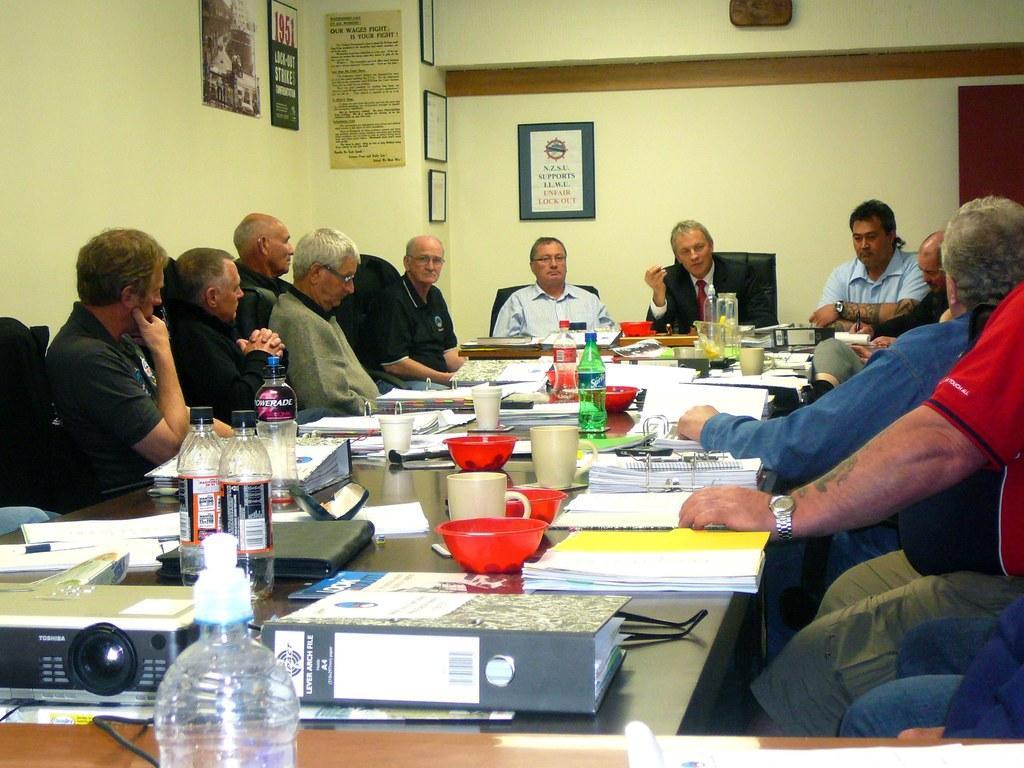In one or two sentences, can you explain what this image depicts? In this picture we can see some people are sitting on chairs in front of a table, there are some files, bottles, mugs, bowls, a projector present on the table, in the background there is a wall, there are some boards on the wall, we can see some text on these boards. 